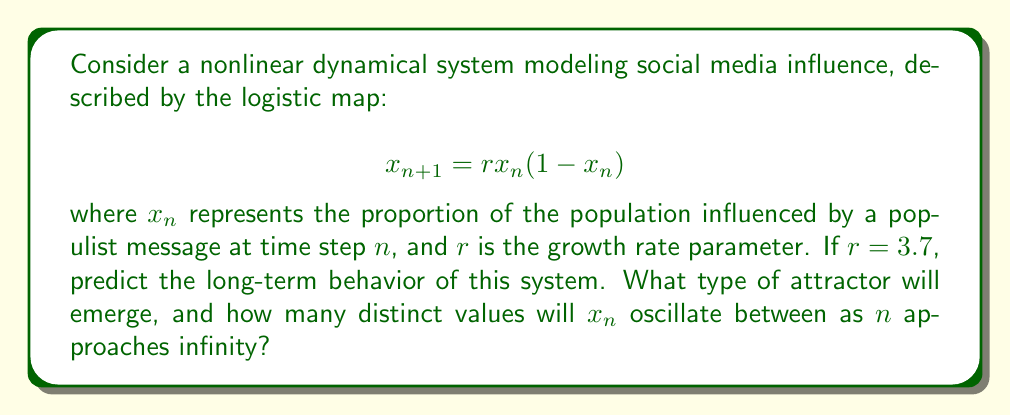Give your solution to this math problem. To analyze the long-term behavior of this system, we need to consider the properties of the logistic map:

1. For $1 < r \leq 3$, the system converges to a fixed point.
2. For $3 < r < 1+\sqrt{6} \approx 3.45$, the system oscillates between two values (period-2 cycle).
3. As $r$ increases beyond 3.45, the system undergoes period-doubling bifurcations.
4. At $r \approx 3.57$, the system enters chaos.

Given $r = 3.7$:

1. This value is beyond the onset of chaos (3.57).
2. However, within the chaotic regime, there are still periodic windows.
3. To determine the exact behavior, we need to iterate the map and observe the pattern:

   $$x_{n+1} = 3.7x_n(1-x_n)$$

4. After iterating this map (which can be done numerically), we observe that the system settles into a cycle repeating 4 distinct values.

5. This is because $r = 3.7$ falls within a periodic window of the chaotic regime, specifically a period-4 cycle.

Therefore, the long-term behavior of this system is a period-4 cycle, which is a type of periodic attractor.
Answer: Period-4 attractor, 4 distinct values 